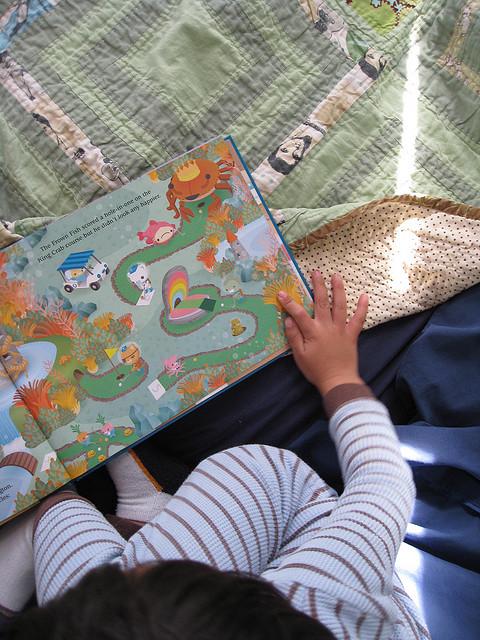Is the game fun?
Give a very brief answer. Yes. What is the child wearing?
Concise answer only. Pajamas. What is this child touching?
Give a very brief answer. Book. 